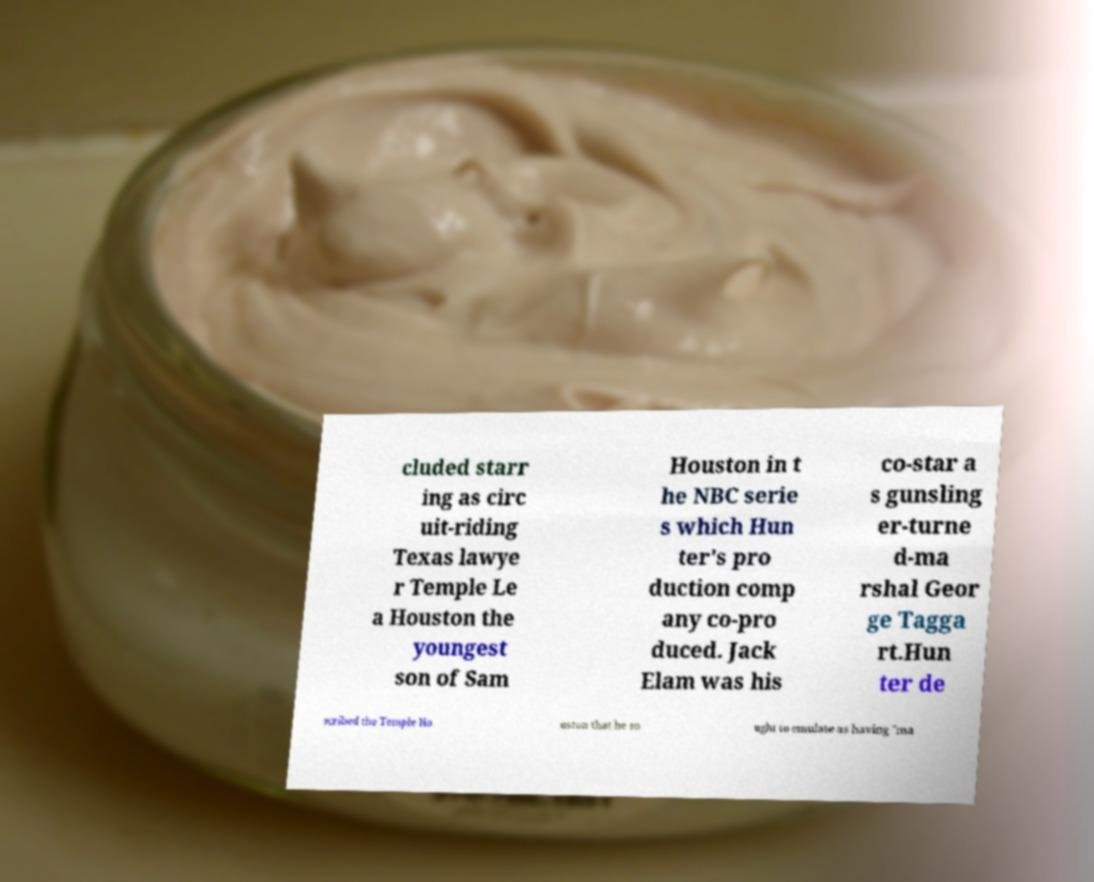There's text embedded in this image that I need extracted. Can you transcribe it verbatim? cluded starr ing as circ uit-riding Texas lawye r Temple Le a Houston the youngest son of Sam Houston in t he NBC serie s which Hun ter's pro duction comp any co-pro duced. Jack Elam was his co-star a s gunsling er-turne d-ma rshal Geor ge Tagga rt.Hun ter de scribed the Temple Ho uston that he so ught to emulate as having "ma 